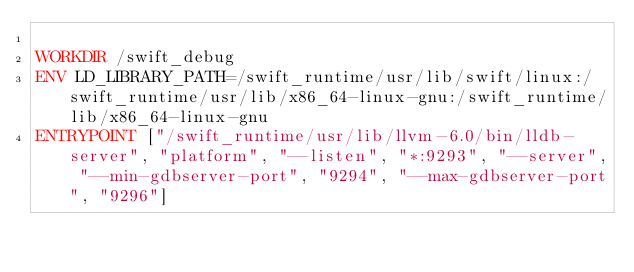<code> <loc_0><loc_0><loc_500><loc_500><_Dockerfile_>
WORKDIR /swift_debug
ENV LD_LIBRARY_PATH=/swift_runtime/usr/lib/swift/linux:/swift_runtime/usr/lib/x86_64-linux-gnu:/swift_runtime/lib/x86_64-linux-gnu
ENTRYPOINT ["/swift_runtime/usr/lib/llvm-6.0/bin/lldb-server", "platform", "--listen", "*:9293", "--server", "--min-gdbserver-port", "9294", "--max-gdbserver-port", "9296"]

</code> 